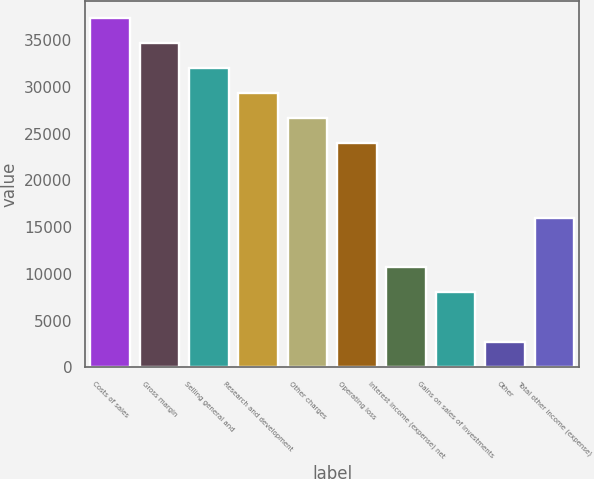Convert chart. <chart><loc_0><loc_0><loc_500><loc_500><bar_chart><fcel>Costs of sales<fcel>Gross margin<fcel>Selling general and<fcel>Research and development<fcel>Other charges<fcel>Operating loss<fcel>Interest income (expense) net<fcel>Gains on sales of investments<fcel>Other<fcel>Total other income (expense)<nl><fcel>37332.4<fcel>34666.8<fcel>32001.2<fcel>29335.6<fcel>26670<fcel>24004.4<fcel>10676.4<fcel>8010.8<fcel>2679.6<fcel>16007.6<nl></chart> 